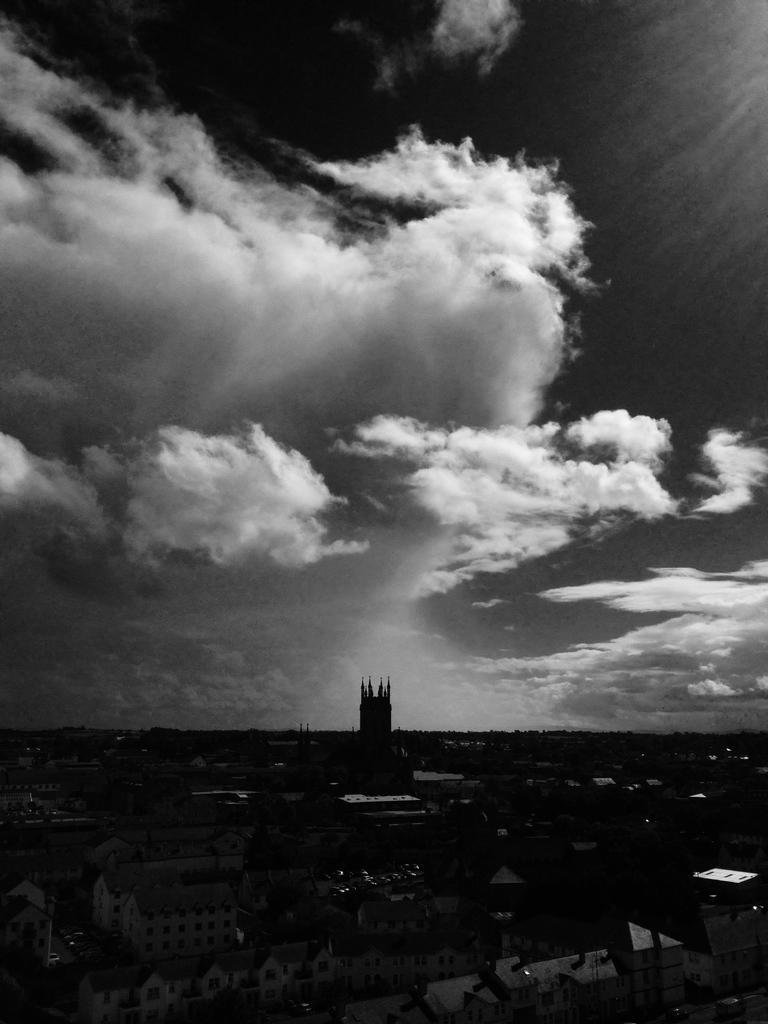What type of structures can be seen in the image? There are buildings in the image. How are the buildings arranged in the image? The buildings are arranged from left to right. What is the condition of the sky in the image? The sky is cloudy in the image. What type of rock can be seen in the image? There is no rock present in the image; it features buildings and a cloudy sky. How does the wind blow in the image? There is no wind or blowing action depicted in the image. 